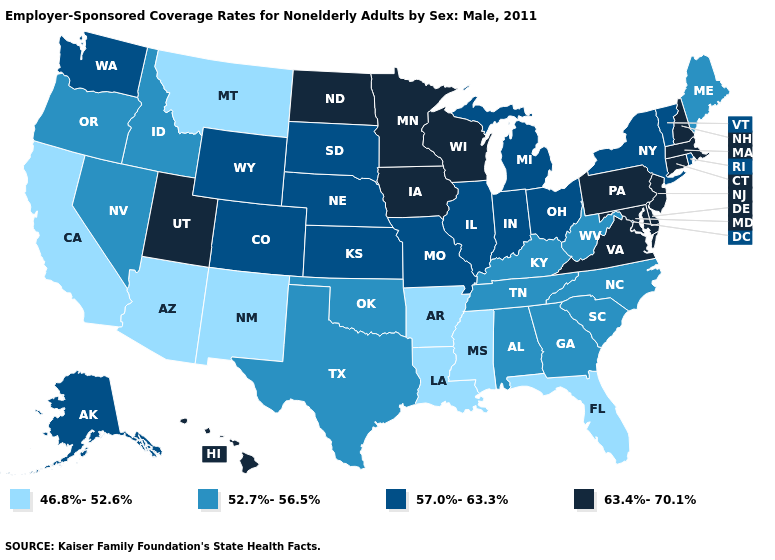Among the states that border Oklahoma , which have the highest value?
Be succinct. Colorado, Kansas, Missouri. Does California have the lowest value in the USA?
Keep it brief. Yes. Is the legend a continuous bar?
Answer briefly. No. What is the lowest value in the MidWest?
Keep it brief. 57.0%-63.3%. Does the first symbol in the legend represent the smallest category?
Give a very brief answer. Yes. Does Utah have a higher value than New Hampshire?
Answer briefly. No. Does New Mexico have the lowest value in the USA?
Keep it brief. Yes. What is the lowest value in states that border Louisiana?
Concise answer only. 46.8%-52.6%. Name the states that have a value in the range 63.4%-70.1%?
Keep it brief. Connecticut, Delaware, Hawaii, Iowa, Maryland, Massachusetts, Minnesota, New Hampshire, New Jersey, North Dakota, Pennsylvania, Utah, Virginia, Wisconsin. Name the states that have a value in the range 46.8%-52.6%?
Be succinct. Arizona, Arkansas, California, Florida, Louisiana, Mississippi, Montana, New Mexico. What is the value of Iowa?
Short answer required. 63.4%-70.1%. What is the value of South Carolina?
Concise answer only. 52.7%-56.5%. Name the states that have a value in the range 57.0%-63.3%?
Quick response, please. Alaska, Colorado, Illinois, Indiana, Kansas, Michigan, Missouri, Nebraska, New York, Ohio, Rhode Island, South Dakota, Vermont, Washington, Wyoming. Name the states that have a value in the range 46.8%-52.6%?
Short answer required. Arizona, Arkansas, California, Florida, Louisiana, Mississippi, Montana, New Mexico. Does North Dakota have the same value as California?
Write a very short answer. No. 